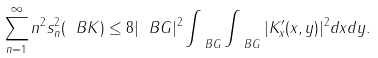Convert formula to latex. <formula><loc_0><loc_0><loc_500><loc_500>\sum _ { n = 1 } ^ { \infty } n ^ { 2 } s ^ { 2 } _ { n } ( \ B K ) \leq 8 | \ B G | ^ { 2 } \int _ { \ B G } \int _ { \ B G } | K ^ { \prime } _ { x } ( x , y ) | ^ { 2 } d x d y .</formula> 